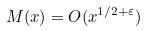<formula> <loc_0><loc_0><loc_500><loc_500>M ( x ) = O ( x ^ { 1 / 2 + \varepsilon } )</formula> 